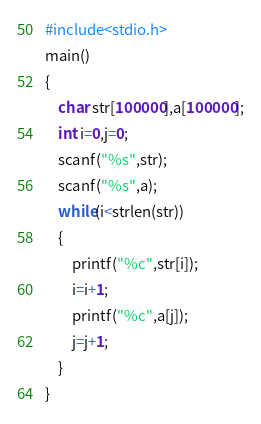Convert code to text. <code><loc_0><loc_0><loc_500><loc_500><_C_>#include<stdio.h>
main()
{
    char str[100000],a[100000];
    int i=0,j=0;
    scanf("%s",str);
    scanf("%s",a);
    while(i<strlen(str))
    {
        printf("%c",str[i]);
        i=i+1;
        printf("%c",a[j]);
        j=j+1;
    }
}
</code> 